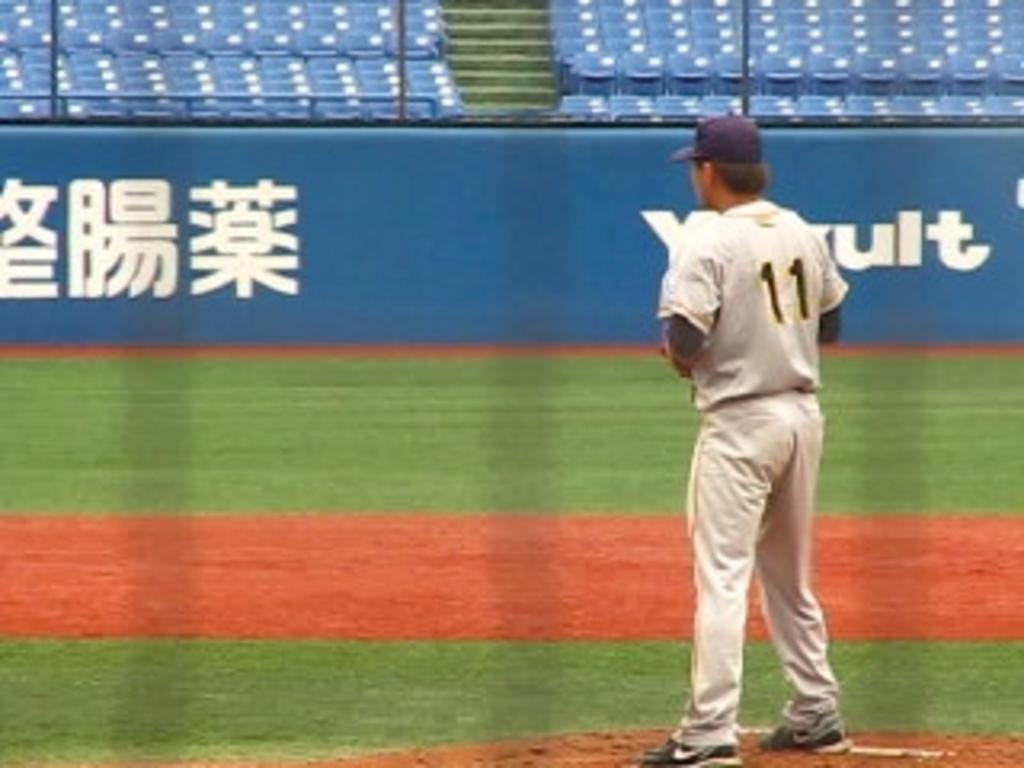<image>
Give a short and clear explanation of the subsequent image. A man in a gray baseball uniform that says 11 on the back 